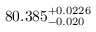Convert formula to latex. <formula><loc_0><loc_0><loc_500><loc_500>8 0 . 3 8 5 _ { - 0 . 0 2 0 } ^ { + 0 . 0 2 2 6 }</formula> 